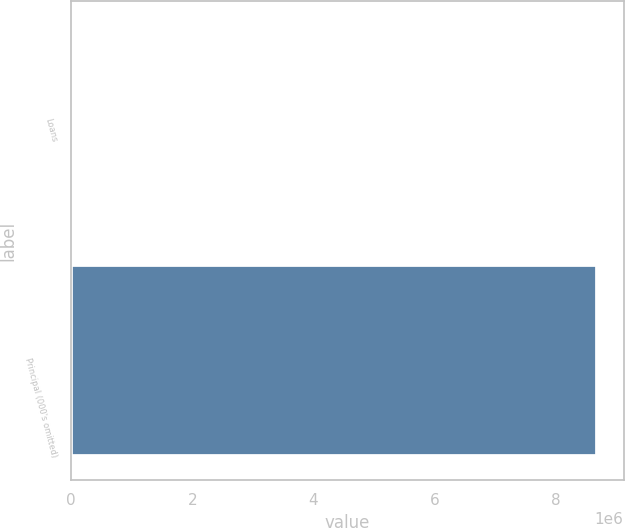Convert chart to OTSL. <chart><loc_0><loc_0><loc_500><loc_500><bar_chart><fcel>Loans<fcel>Principal (000's omitted)<nl><fcel>40269<fcel>8.6835e+06<nl></chart> 